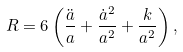<formula> <loc_0><loc_0><loc_500><loc_500>R = 6 \left ( \frac { \ddot { a } } { a } + \frac { \dot { a } ^ { 2 } } { a ^ { 2 } } + \frac { k } { a ^ { 2 } } \right ) ,</formula> 